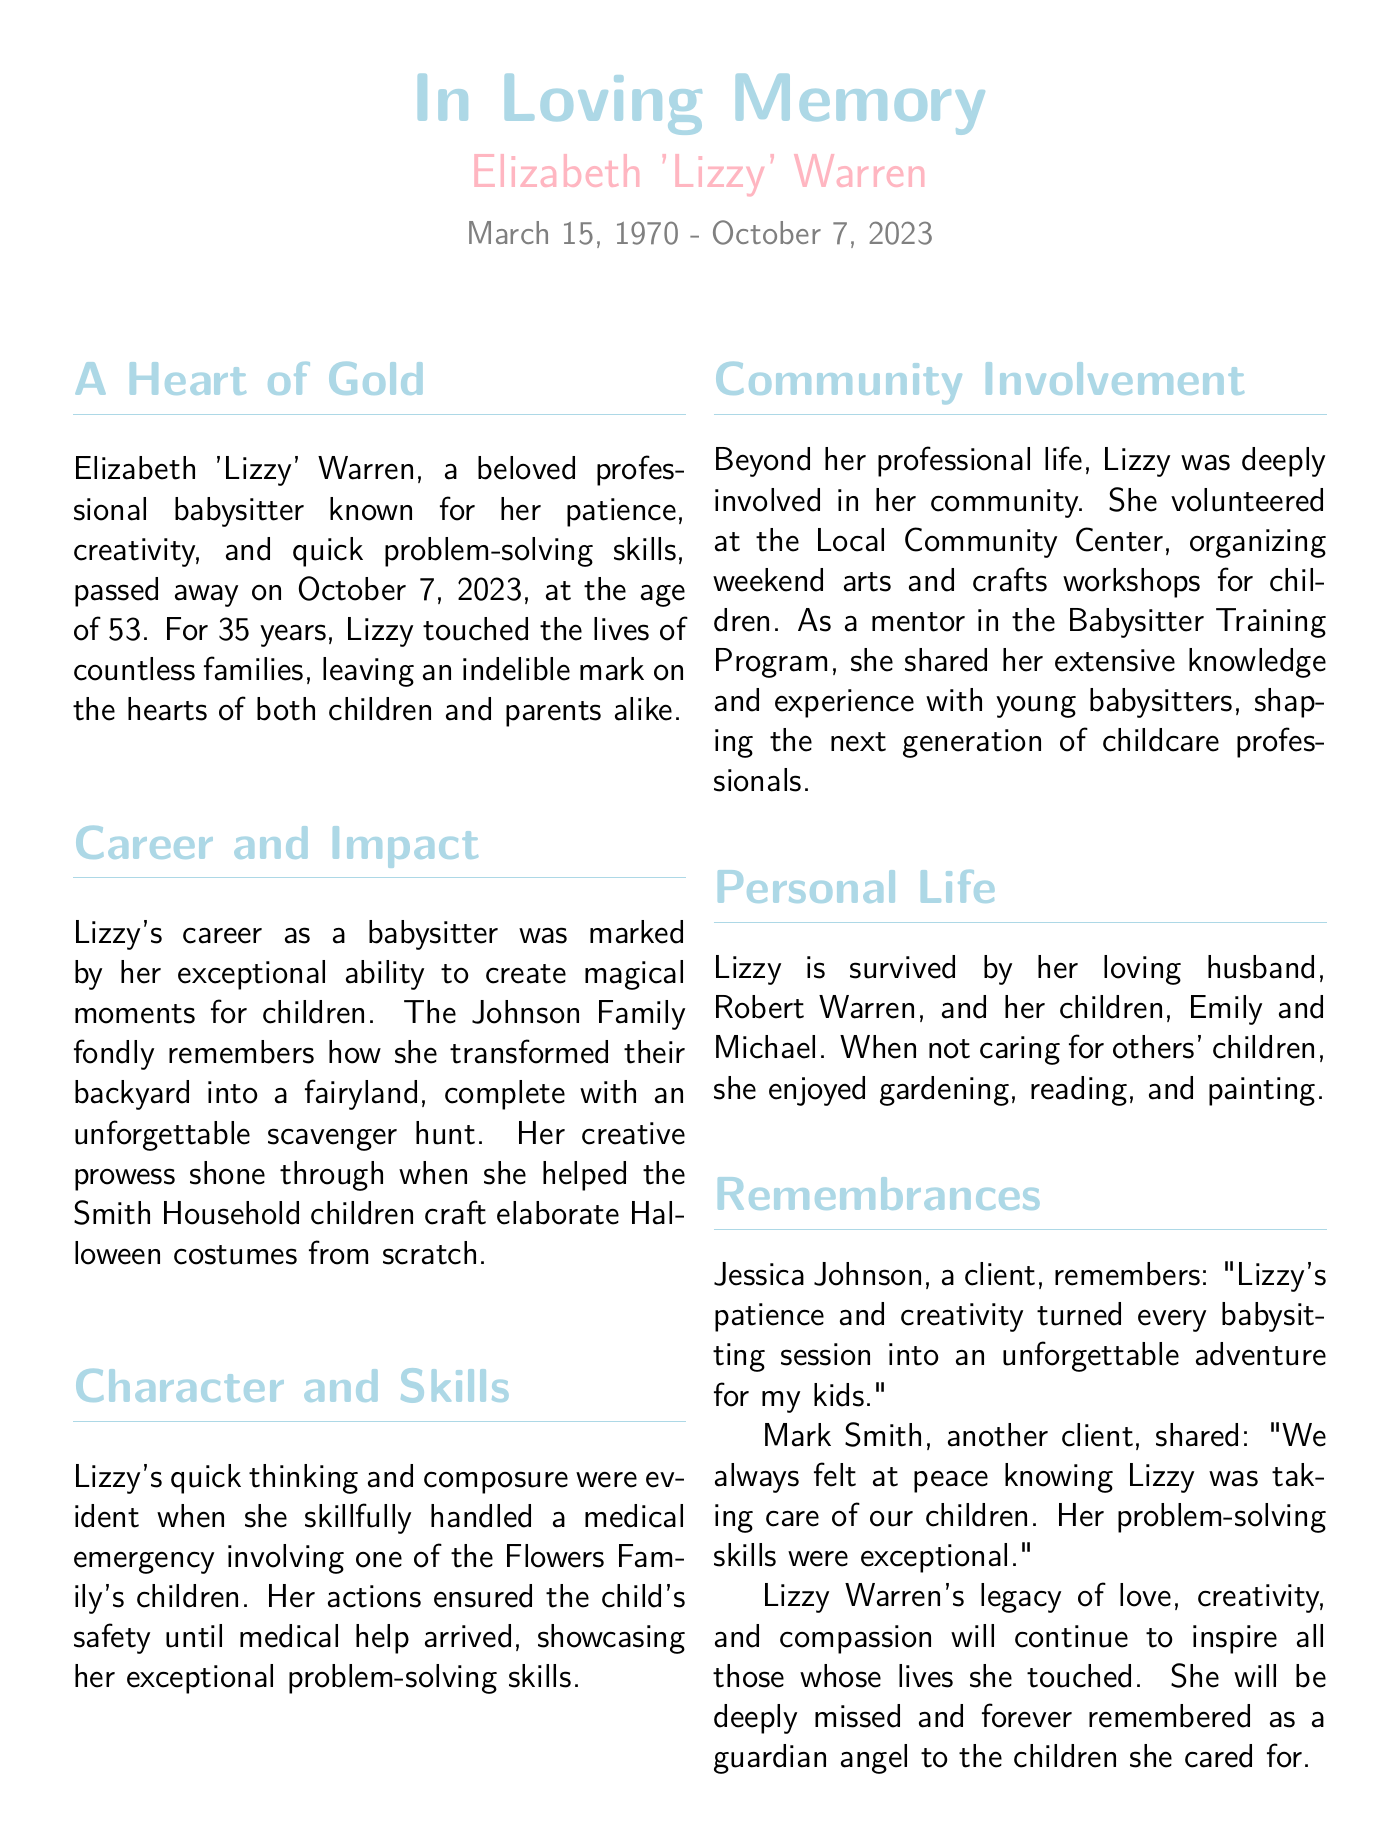what was Elizabeth 'Lizzy' Warren's profession? The document states that Lizzy was a professional babysitter, which highlights her main occupation.
Answer: professional babysitter when did Elizabeth 'Lizzy' Warren pass away? The death date is clearly mentioned in the document, along with her birth date.
Answer: October 7, 2023 how old was Lizzy when she passed away? By subtracting her birth year from her death year, we find her age at the time of death.
Answer: 53 which family remembered her backyard transformation? The Johnson Family's memories are specifically highlighted in relation to Lizzy's creative endeavors.
Answer: Johnson Family what community activity did Lizzy participate in? The document mentions her involvement in organizing weekend arts and crafts workshops at the Local Community Center.
Answer: weekend arts and crafts workshops who survived Elizabeth 'Lizzy' Warren? The text provides details about Lizzy's family, specifically naming her husband and children.
Answer: Robert Warren, Emily, and Michael what was a notable skill shown during a medical emergency? The document refers to her quick thinking and composure during a medical incident, emphasizing her problem-solving abilities.
Answer: problem-solving skills how long was Lizzy's babysitting career? The document mentions Lizzy's experience in years regarding her babysitting profession.
Answer: 35 years which program did Lizzy mentor young babysitters in? The document identifies her involvement in a specific training program related to babysitting.
Answer: Babysitter Training Program 